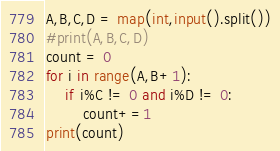<code> <loc_0><loc_0><loc_500><loc_500><_Python_>A,B,C,D = map(int,input().split())
#print(A,B,C,D)
count = 0
for i in range(A,B+1):
    if i%C != 0 and i%D != 0:
        count+=1
print(count)</code> 